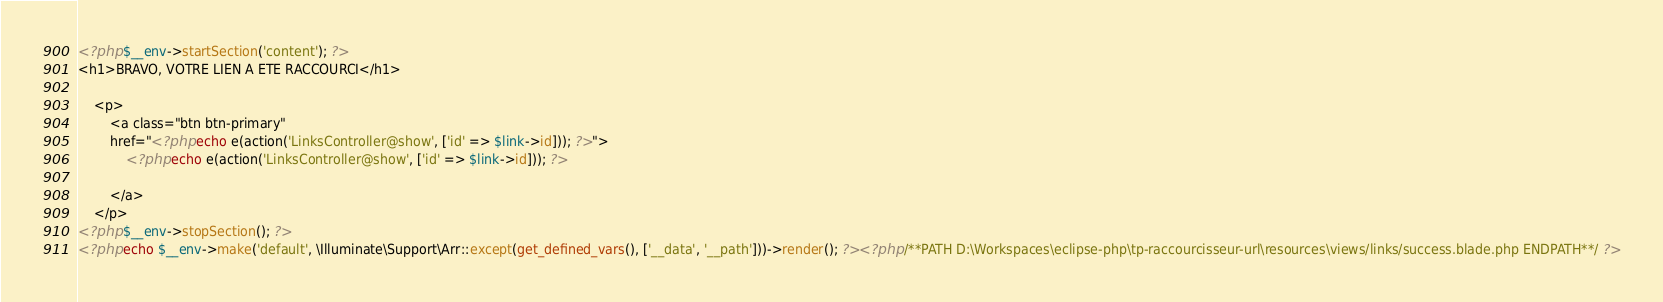Convert code to text. <code><loc_0><loc_0><loc_500><loc_500><_PHP_><?php $__env->startSection('content'); ?> 
<h1>BRAVO, VOTRE LIEN A ETE RACCOURCI</h1>

	<p>
		<a class="btn btn-primary" 
		href="<?php echo e(action('LinksController@show', ['id' => $link->id])); ?>">
			<?php echo e(action('LinksController@show', ['id' => $link->id])); ?>

		</a>
	</p>
<?php $__env->stopSection(); ?>
<?php echo $__env->make('default', \Illuminate\Support\Arr::except(get_defined_vars(), ['__data', '__path']))->render(); ?><?php /**PATH D:\Workspaces\eclipse-php\tp-raccourcisseur-url\resources\views/links/success.blade.php ENDPATH**/ ?></code> 